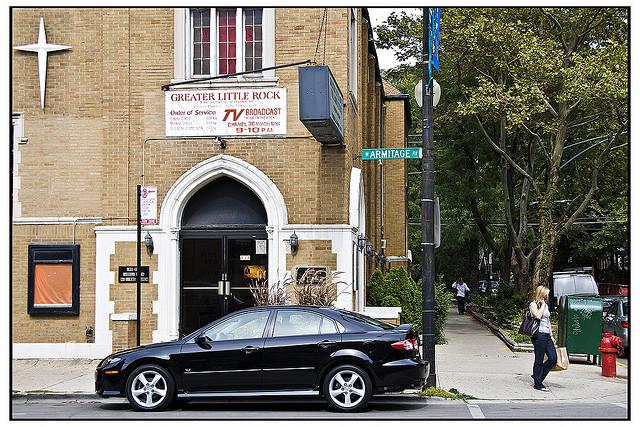Is the car a 2 door or 4 door?
Give a very brief answer. 4 door. How many bags is the lady carrying?
Short answer required. 1. What language is pictured?
Give a very brief answer. English. What color is the car?
Answer briefly. Black. 